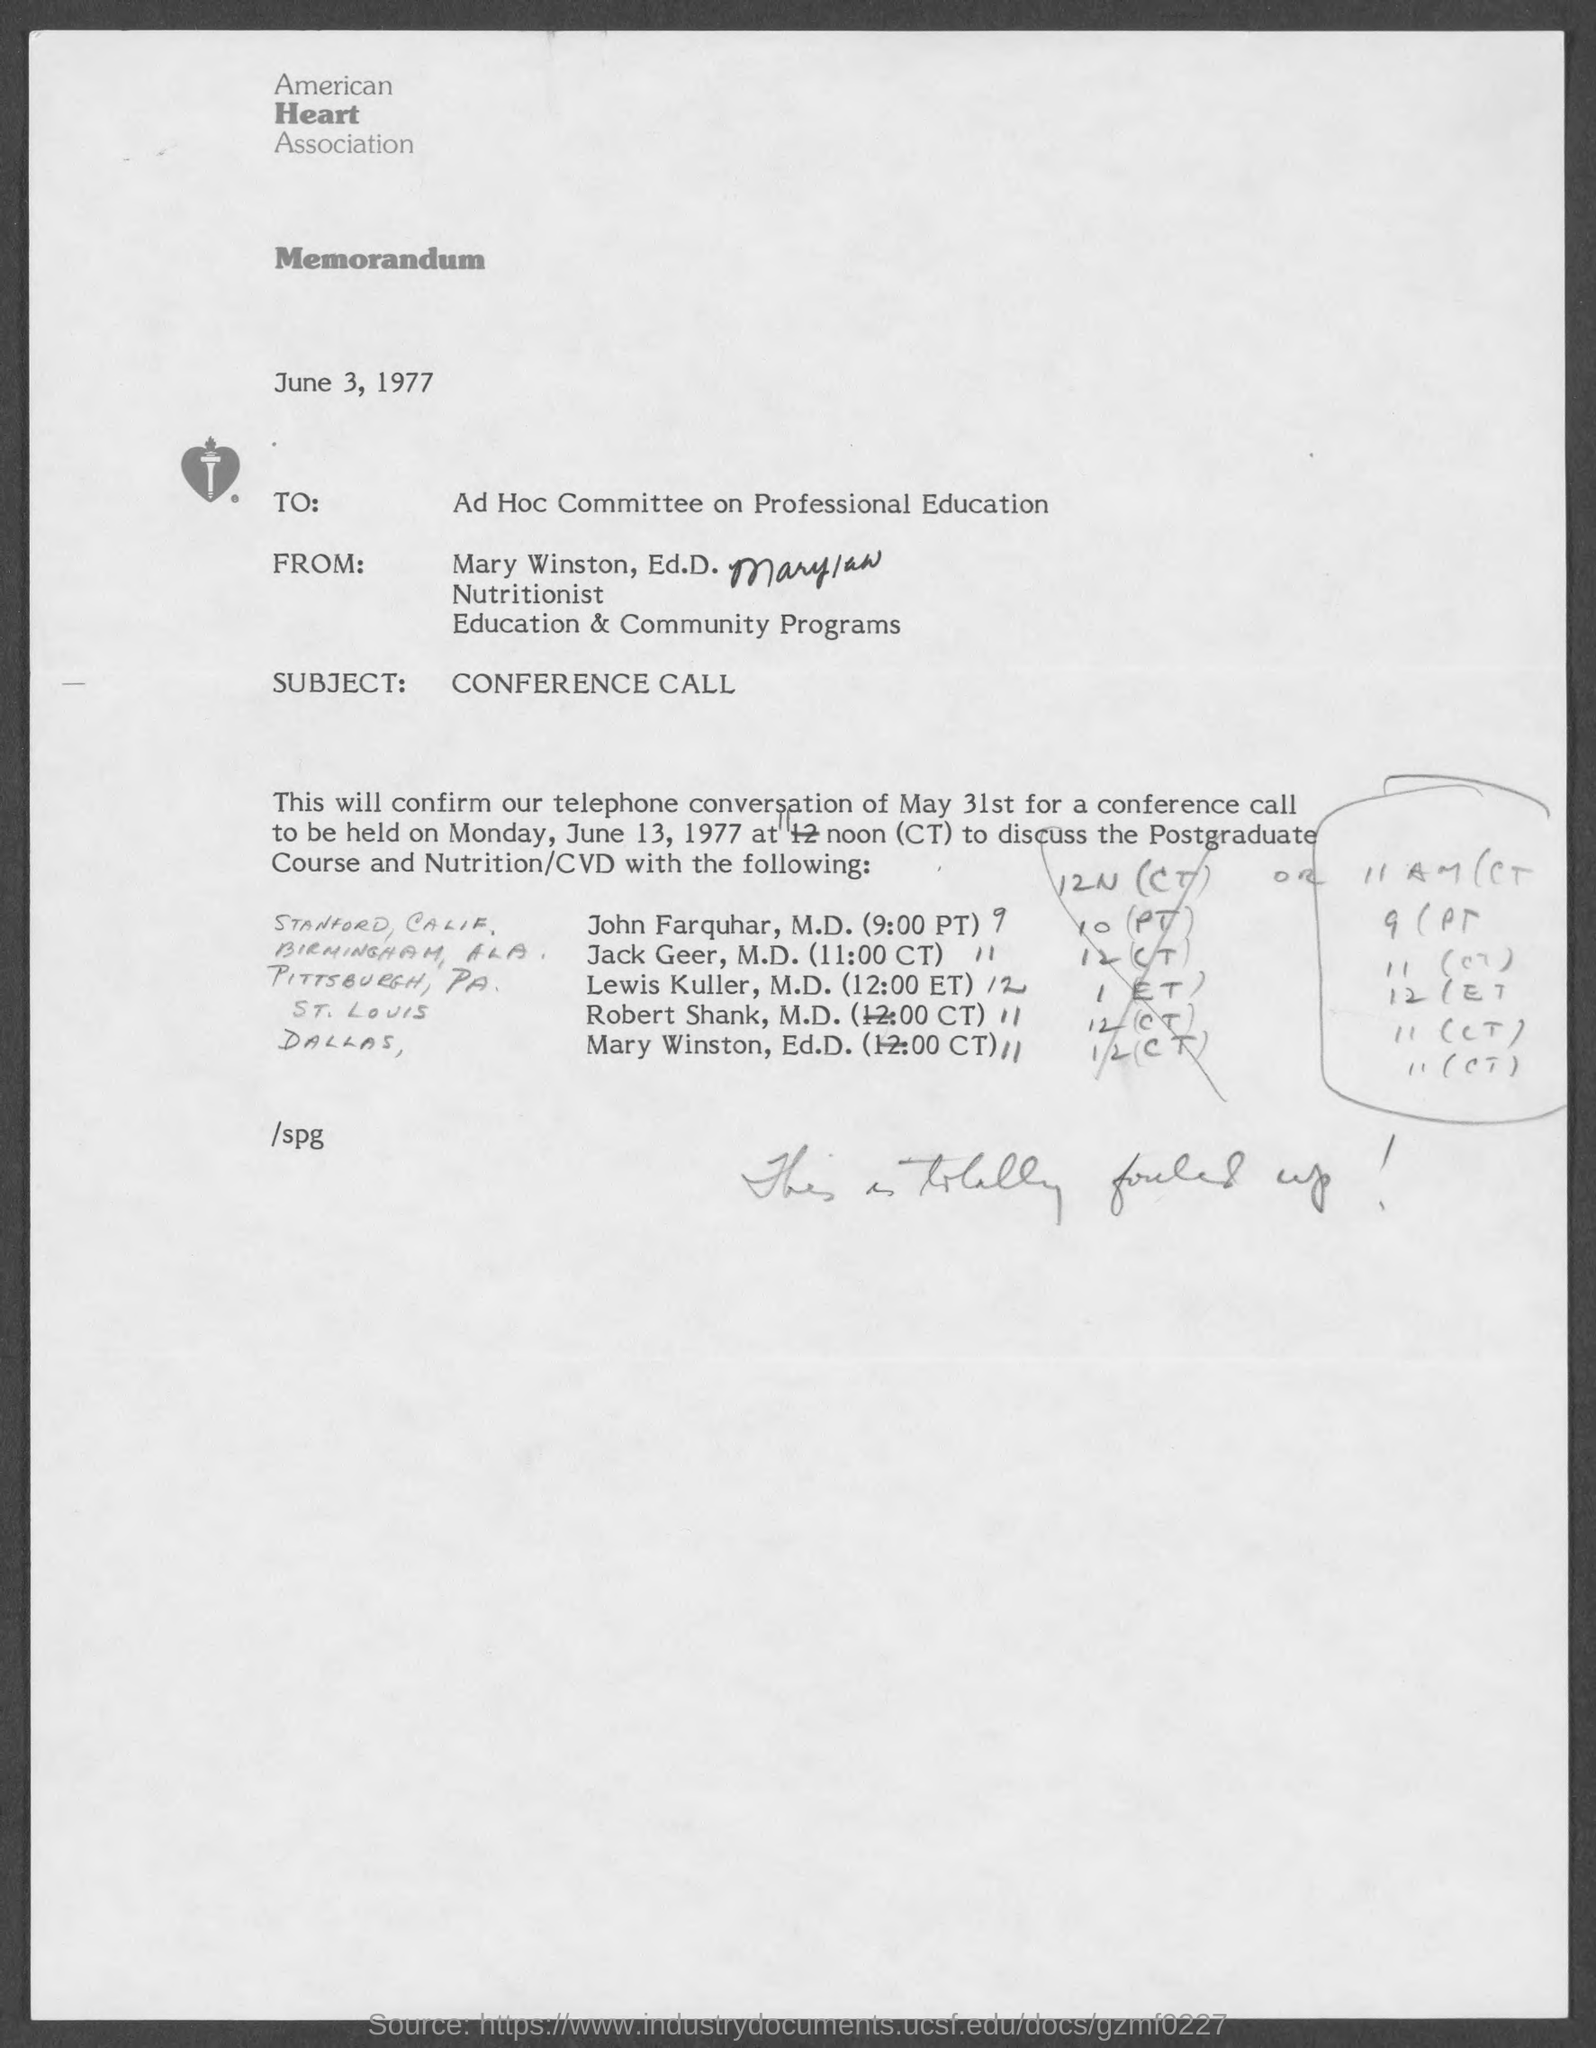Outline some significant characteristics in this image. The memorandum is addressed to an ad hoc committee on professional education. The American Heart Association is mentioned. This is a memorandum, a type of documentation. The subject of the sentence is "conference call. The document is dated June 3, 1977. 